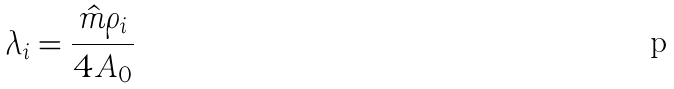Convert formula to latex. <formula><loc_0><loc_0><loc_500><loc_500>\lambda _ { i } = \frac { \hat { m } \rho _ { i } } { 4 A _ { 0 } }</formula> 